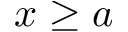<formula> <loc_0><loc_0><loc_500><loc_500>x \geq a</formula> 